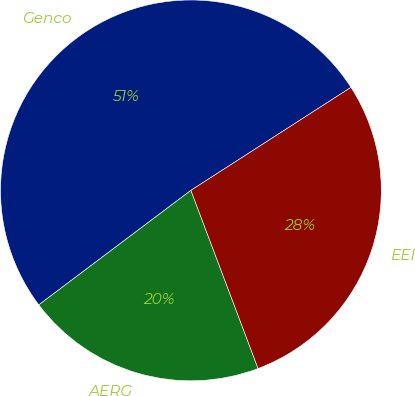Convert chart to OTSL. <chart><loc_0><loc_0><loc_500><loc_500><pie_chart><fcel>Genco<fcel>AERG<fcel>EEI<nl><fcel>51.17%<fcel>20.47%<fcel>28.36%<nl></chart> 